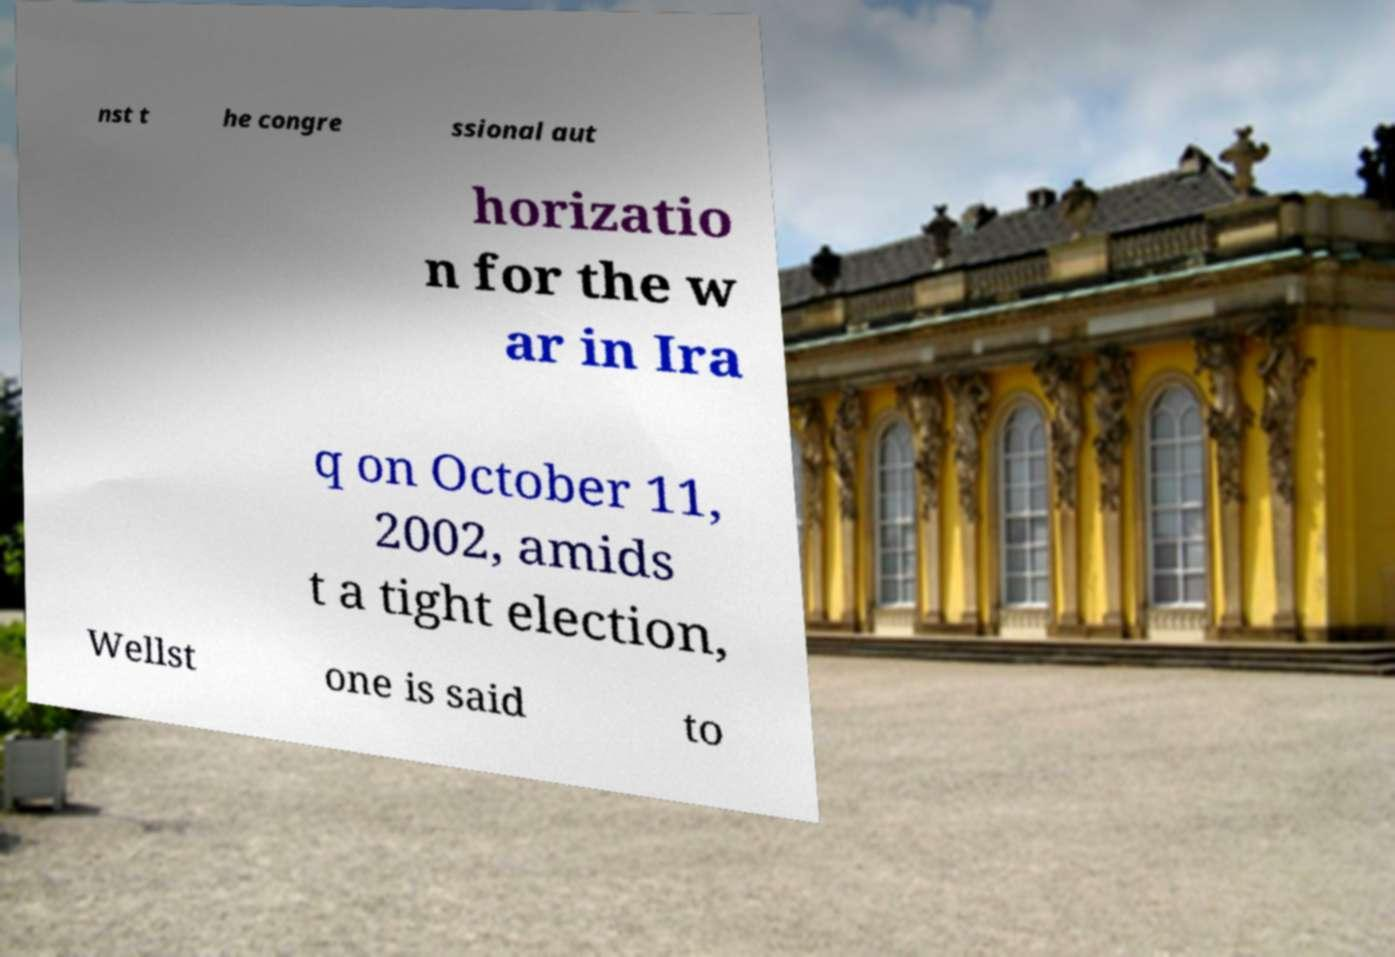Please identify and transcribe the text found in this image. nst t he congre ssional aut horizatio n for the w ar in Ira q on October 11, 2002, amids t a tight election, Wellst one is said to 